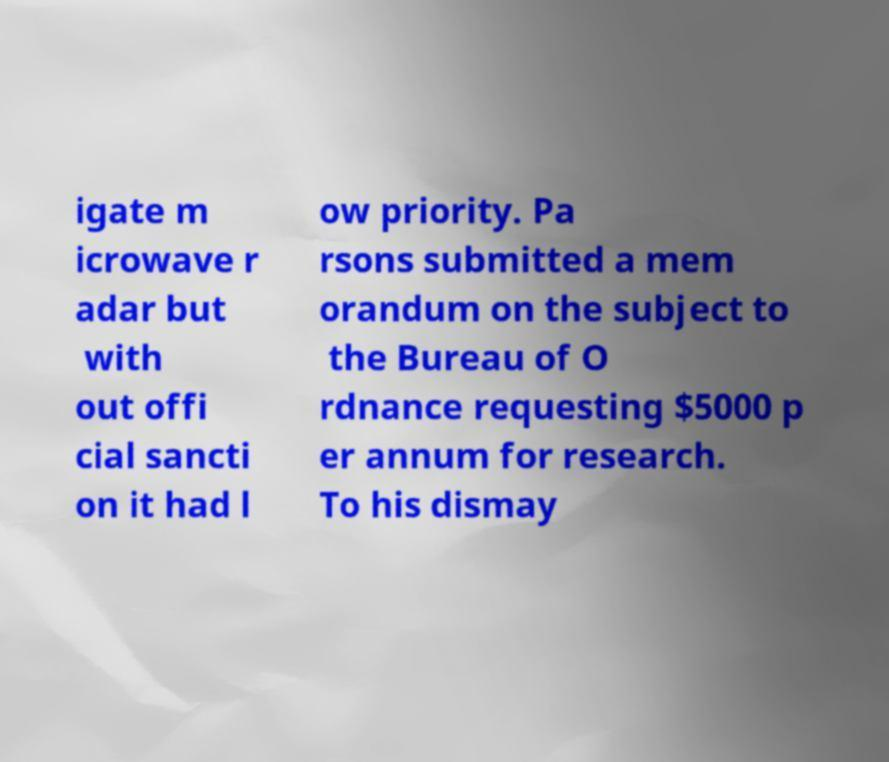Could you assist in decoding the text presented in this image and type it out clearly? igate m icrowave r adar but with out offi cial sancti on it had l ow priority. Pa rsons submitted a mem orandum on the subject to the Bureau of O rdnance requesting $5000 p er annum for research. To his dismay 